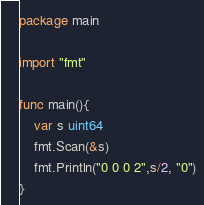Convert code to text. <code><loc_0><loc_0><loc_500><loc_500><_Go_>package main

import "fmt"

func main(){
    var s uint64
    fmt.Scan(&s)
    fmt.Println("0 0 0 2",s/2, "0")
}</code> 